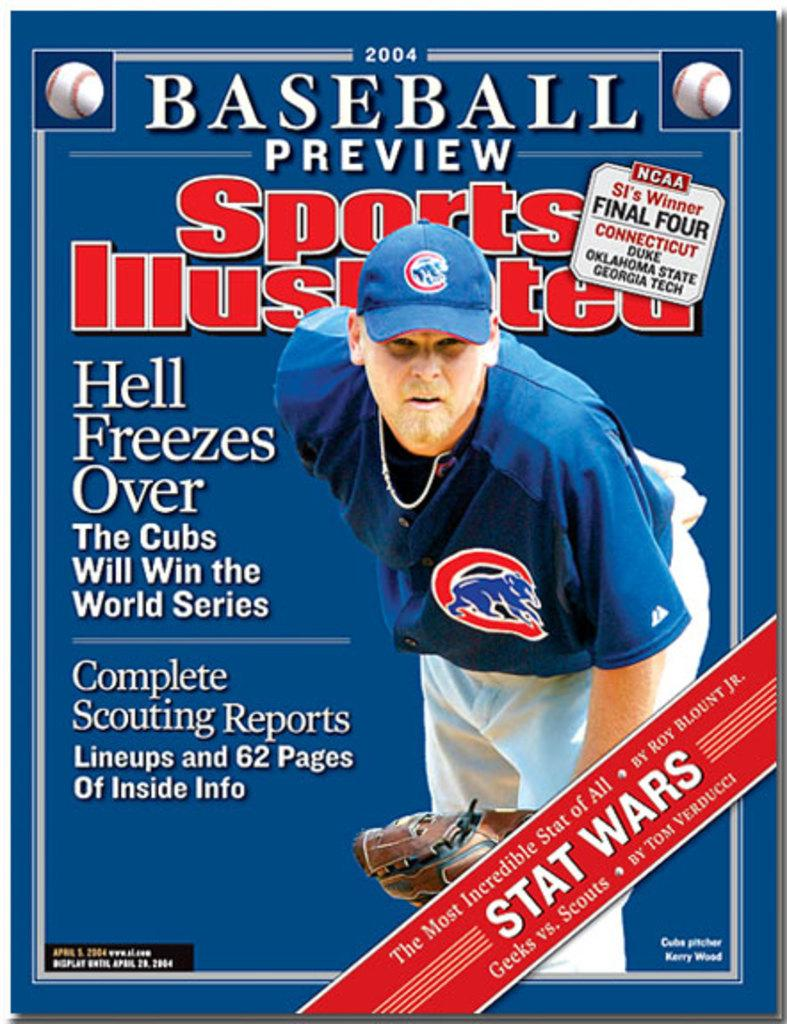<image>
Share a concise interpretation of the image provided. A baseball player on the front cover of a sports illustrated magazine. 